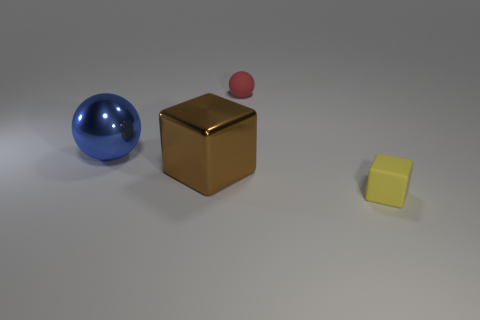Add 3 small rubber cubes. How many objects exist? 7 Subtract 1 red spheres. How many objects are left? 3 Subtract all big blue rubber blocks. Subtract all blue balls. How many objects are left? 3 Add 4 blocks. How many blocks are left? 6 Add 3 big blue things. How many big blue things exist? 4 